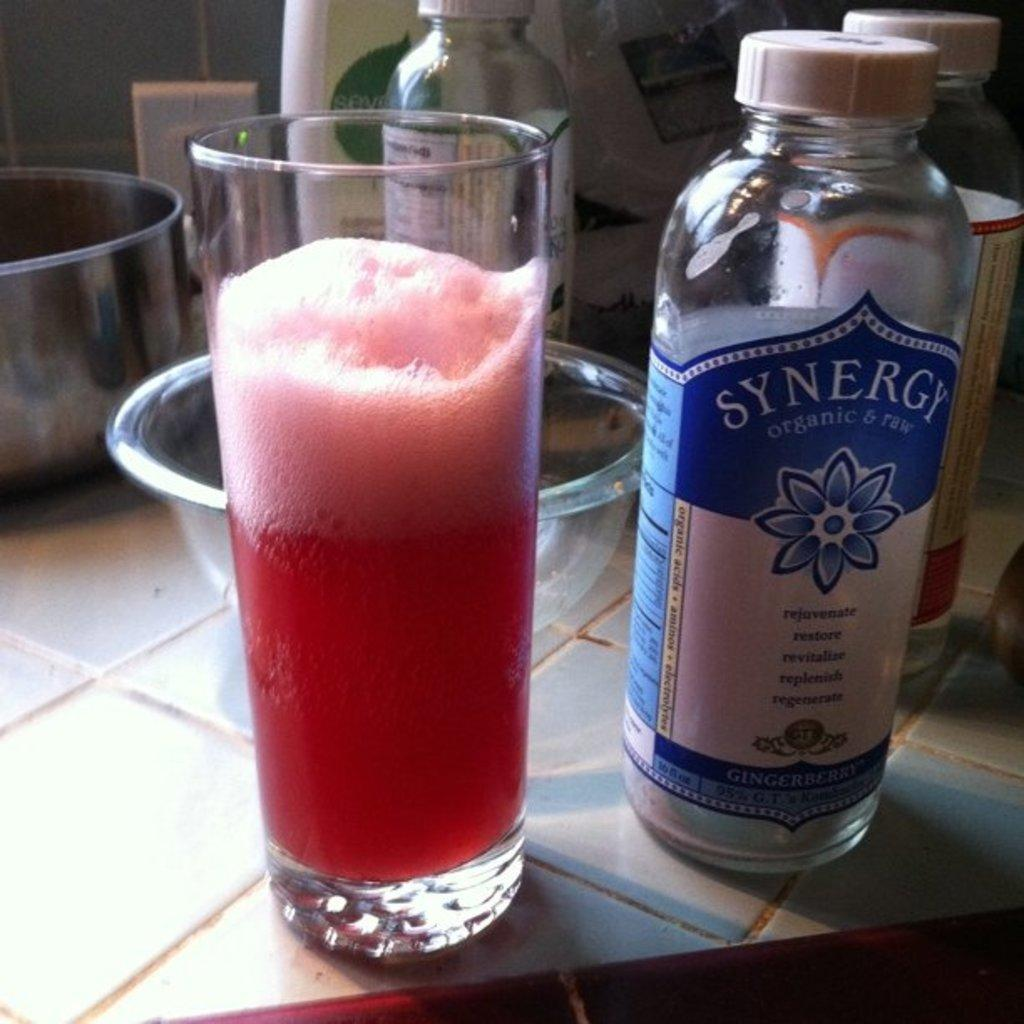<image>
Offer a succinct explanation of the picture presented. Bottle of Synergy Organic & Raw next to a red cup of liquid. 